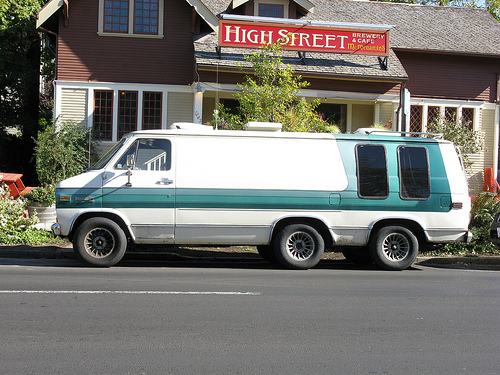<image>
Is the building next to the van? Yes. The building is positioned adjacent to the van, located nearby in the same general area. 